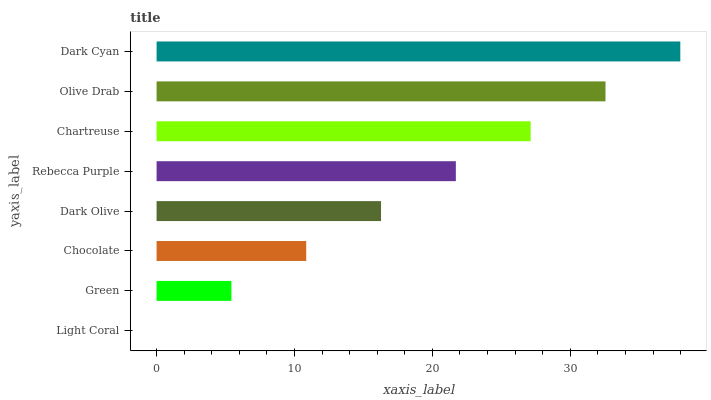Is Light Coral the minimum?
Answer yes or no. Yes. Is Dark Cyan the maximum?
Answer yes or no. Yes. Is Green the minimum?
Answer yes or no. No. Is Green the maximum?
Answer yes or no. No. Is Green greater than Light Coral?
Answer yes or no. Yes. Is Light Coral less than Green?
Answer yes or no. Yes. Is Light Coral greater than Green?
Answer yes or no. No. Is Green less than Light Coral?
Answer yes or no. No. Is Rebecca Purple the high median?
Answer yes or no. Yes. Is Dark Olive the low median?
Answer yes or no. Yes. Is Dark Cyan the high median?
Answer yes or no. No. Is Light Coral the low median?
Answer yes or no. No. 